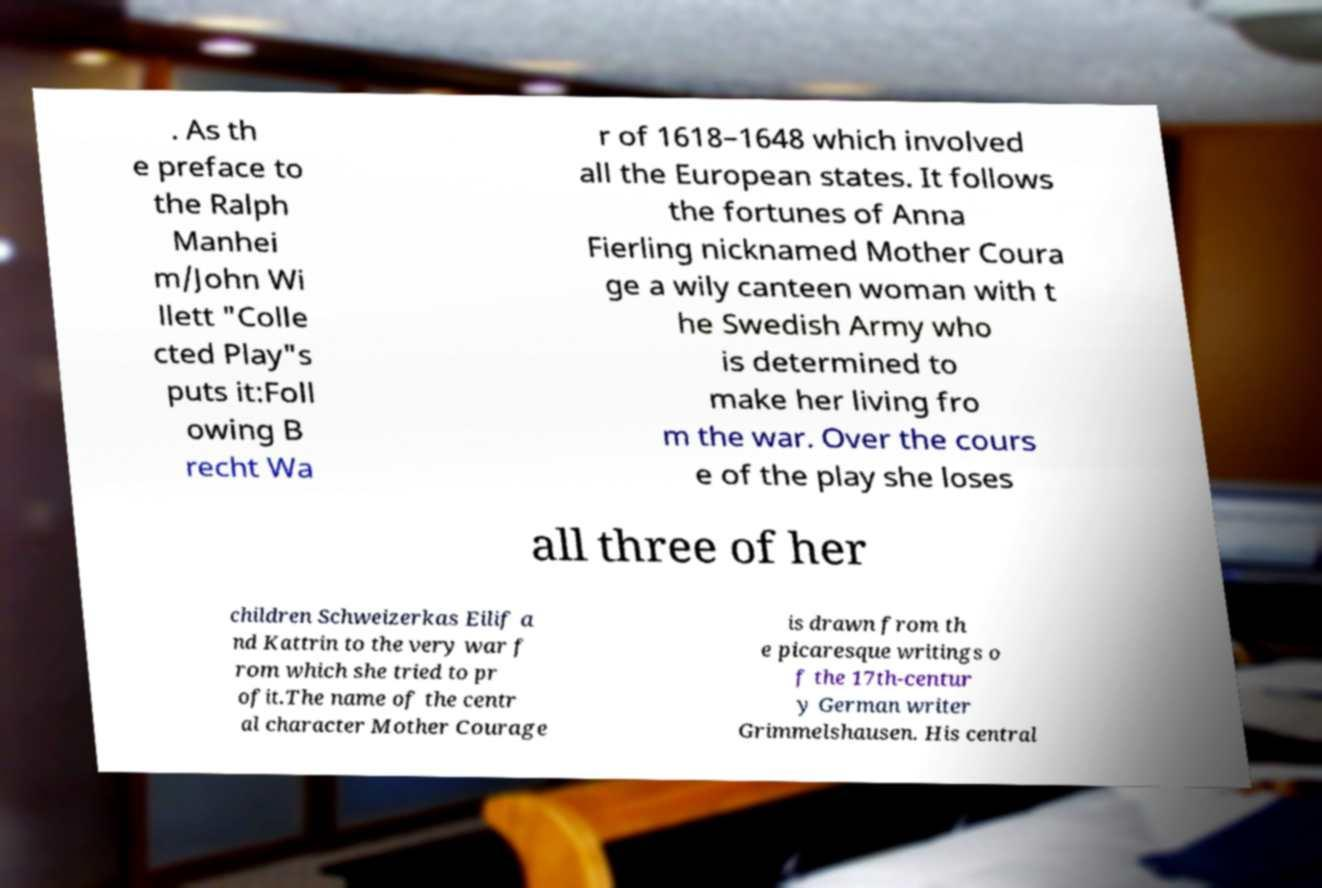Please identify and transcribe the text found in this image. . As th e preface to the Ralph Manhei m/John Wi llett "Colle cted Play"s puts it:Foll owing B recht Wa r of 1618–1648 which involved all the European states. It follows the fortunes of Anna Fierling nicknamed Mother Coura ge a wily canteen woman with t he Swedish Army who is determined to make her living fro m the war. Over the cours e of the play she loses all three of her children Schweizerkas Eilif a nd Kattrin to the very war f rom which she tried to pr ofit.The name of the centr al character Mother Courage is drawn from th e picaresque writings o f the 17th-centur y German writer Grimmelshausen. His central 